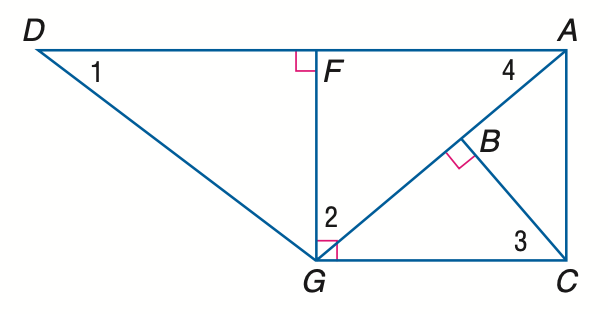Answer the mathemtical geometry problem and directly provide the correct option letter.
Question: Find the measure of \angle 1 if m \angle D G F = 53 and m \angle A G C = 40.
Choices: A: 30 B: 37 C: 40 D: 50 B 